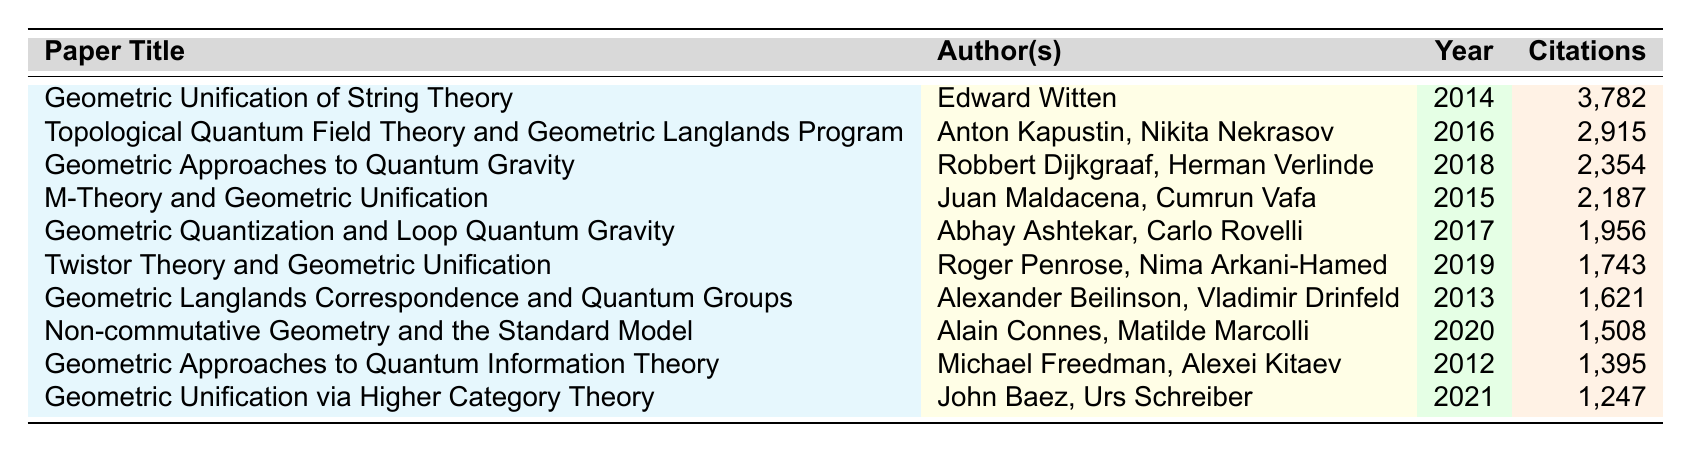What is the title of the paper with the highest citations? The paper with the highest citations is listed first in the table. Looking at the "Citations" column, "Geometric Unification of String Theory" by Edward Witten has 3,782 citations.
Answer: Geometric Unification of String Theory Which paper, published in 2019, has the highest citations? The table provides information about the citations of papers. The only paper published in 2019 is "Twistor Theory and Geometric Unification" by Roger Penrose and Nima Arkani-Hamed, which has 1,743 citations.
Answer: Twistor Theory and Geometric Unification What is the citation difference between the 2016 paper and the 2020 paper? The citations for the 2016 paper "Topological Quantum Field Theory and Geometric Langlands Program" are 2,915, and for the 2020 paper "Non-commutative Geometry and the Standard Model," it is 1,508. The difference is calculated as 2,915 - 1,508 = 1,407.
Answer: 1407 Which authors contributed to the paper with the least citations? The paper with the least citations is "Geometric Unification via Higher Category Theory," which has 1,247 citations. This paper was authored by John Baez and Urs Schreiber.
Answer: John Baez, Urs Schreiber What is the average number of citations for the three most cited papers? The three most cited papers have citations of 3,782, 2,915, and 2,354. The total citations are 3,782 + 2,915 + 2,354 = 9,051. To find the average, divide by 3, resulting in 9,051 / 3 = 3,017.
Answer: 3017 Is there a paper from 2014 with more than 2,000 citations? The paper "Geometric Unification of String Theory" from 2014 has 3,782 citations, which is indeed more than 2,000.
Answer: Yes What percentage of total citations does the 2017 paper account for, assuming total citations are 15,500? The 2017 paper "Geometric Quantization and Loop Quantum Gravity" has 1,956 citations. The percentage is calculated as (1,956 / 15,500) * 100 = 12.6%.
Answer: 12.6% Which year has the highest average citations across all published papers? To determine the year with the highest average citations, calculate the citations grouped by year: For 2014 - 3,782, 2015 - 2,187, 2016 - 2,915, 2017 - 1,956, 2018 - 2,354, 2019 - 1,743, 2020 - 1,508, and 2021 - 1,247. The averages are varied, with 2016 showing strong performance at 2,915, while 2021 has the lowest average at 1,247. Hence, 2016 has the highest average.
Answer: 2016 Who are the authors of the paper published in 2012 with the least citations? The paper published in 2012 is "Geometric Approaches to Quantum Information Theory" with 1,395 citations. The authors are Michael Freedman and Alexei Kitaev.
Answer: Michael Freedman, Alexei Kitaev 